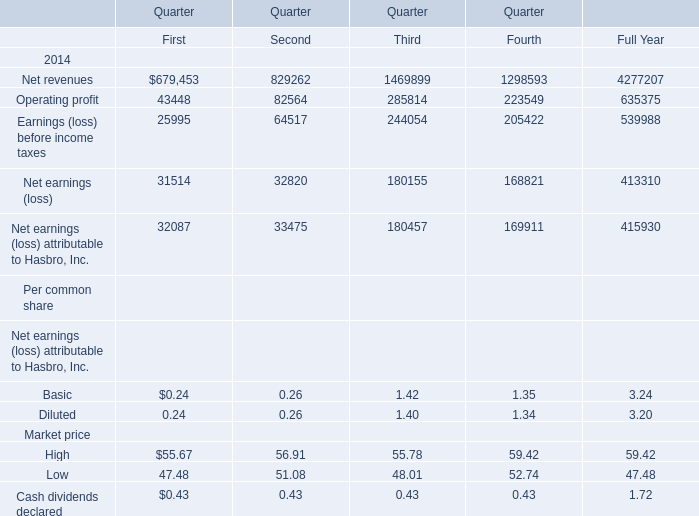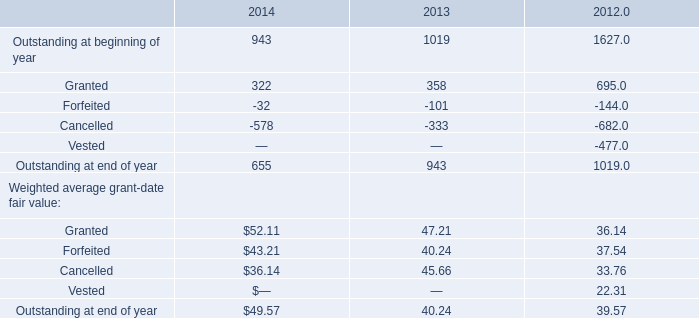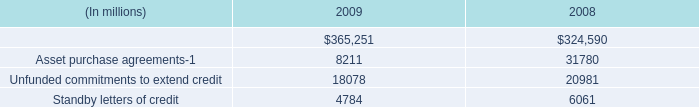What's the sum of the Operating profit in Table 0 in the years where Forfeited of Weighted average grant-date fair value in Table 1 is greater than 43? 
Computations: (((43448 + 82564) + 285814) + 223549)
Answer: 635375.0. 